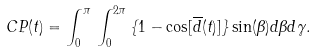Convert formula to latex. <formula><loc_0><loc_0><loc_500><loc_500>C P ( t ) = \int _ { 0 } ^ { \pi } \, \int _ { 0 } ^ { 2 \pi } \, \{ 1 - \cos [ \overline { d } ( t ) ] \} \sin ( \beta ) d \beta d \gamma .</formula> 